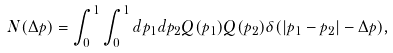Convert formula to latex. <formula><loc_0><loc_0><loc_500><loc_500>N ( \Delta p ) = \int _ { 0 } ^ { 1 } \int _ { 0 } ^ { 1 } d p _ { 1 } d p _ { 2 } Q ( p _ { 1 } ) Q ( p _ { 2 } ) \delta ( | p _ { 1 } - p _ { 2 } | - \Delta p ) ,</formula> 